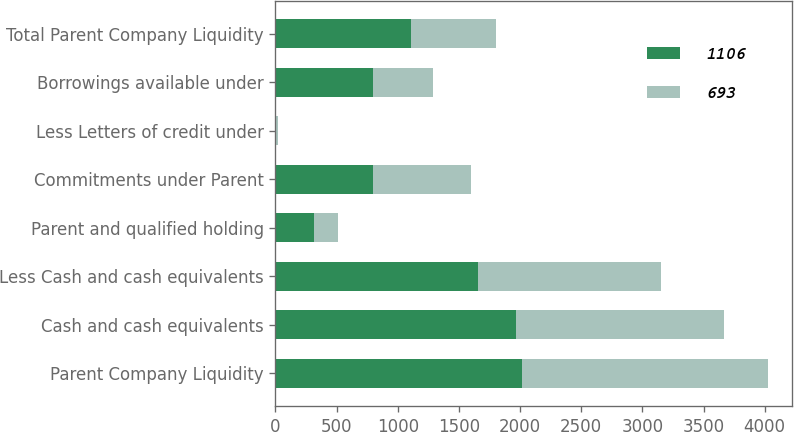Convert chart to OTSL. <chart><loc_0><loc_0><loc_500><loc_500><stacked_bar_chart><ecel><fcel>Parent Company Liquidity<fcel>Cash and cash equivalents<fcel>Less Cash and cash equivalents<fcel>Parent and qualified holding<fcel>Commitments under Parent<fcel>Less Letters of credit under<fcel>Borrowings available under<fcel>Total Parent Company Liquidity<nl><fcel>1106<fcel>2012<fcel>1970<fcel>1659<fcel>311<fcel>800<fcel>5<fcel>795<fcel>1106<nl><fcel>693<fcel>2011<fcel>1695<fcel>1495<fcel>200<fcel>800<fcel>12<fcel>493<fcel>693<nl></chart> 